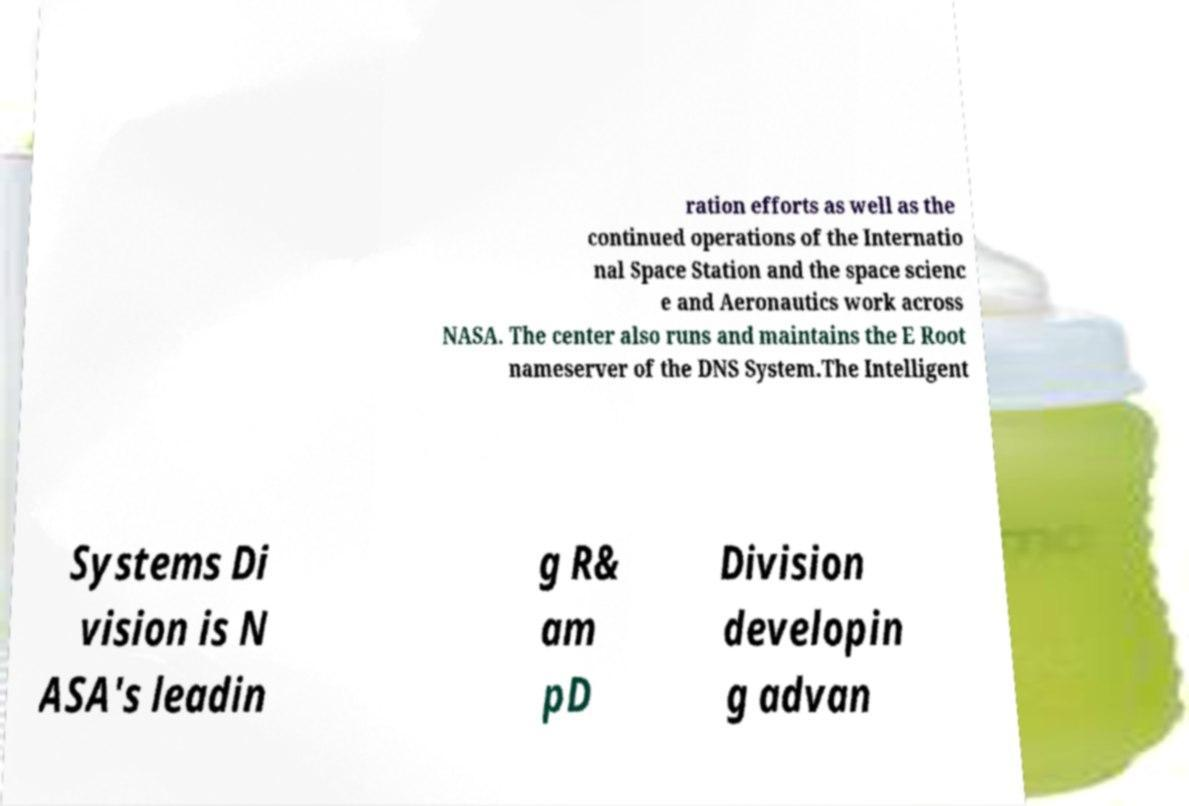There's text embedded in this image that I need extracted. Can you transcribe it verbatim? ration efforts as well as the continued operations of the Internatio nal Space Station and the space scienc e and Aeronautics work across NASA. The center also runs and maintains the E Root nameserver of the DNS System.The Intelligent Systems Di vision is N ASA's leadin g R& am pD Division developin g advan 